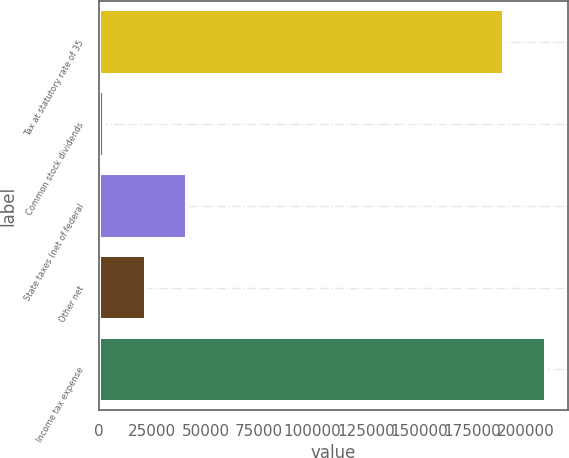Convert chart. <chart><loc_0><loc_0><loc_500><loc_500><bar_chart><fcel>Tax at statutory rate of 35<fcel>Common stock dividends<fcel>State taxes (net of federal<fcel>Other net<fcel>Income tax expense<nl><fcel>189764<fcel>2570<fcel>41384.4<fcel>21977.2<fcel>209171<nl></chart> 